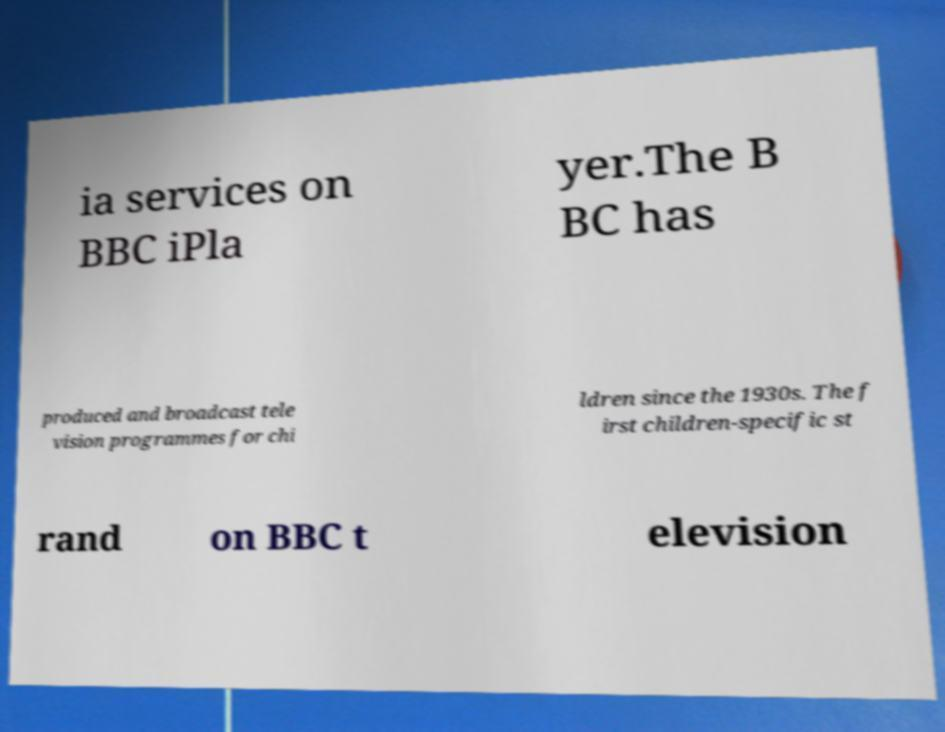Could you assist in decoding the text presented in this image and type it out clearly? ia services on BBC iPla yer.The B BC has produced and broadcast tele vision programmes for chi ldren since the 1930s. The f irst children-specific st rand on BBC t elevision 